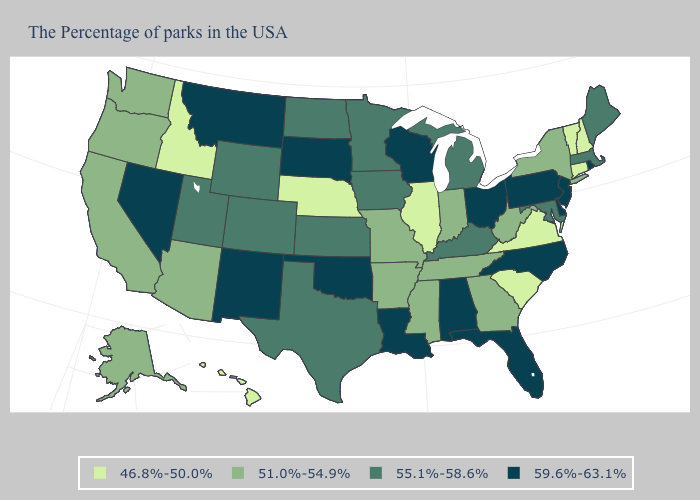What is the lowest value in the MidWest?
Short answer required. 46.8%-50.0%. Does Virginia have the lowest value in the USA?
Short answer required. Yes. Does Alabama have the highest value in the USA?
Be succinct. Yes. Name the states that have a value in the range 51.0%-54.9%?
Answer briefly. New York, West Virginia, Georgia, Indiana, Tennessee, Mississippi, Missouri, Arkansas, Arizona, California, Washington, Oregon, Alaska. Does Indiana have a lower value than Nebraska?
Give a very brief answer. No. Among the states that border Washington , does Oregon have the highest value?
Answer briefly. Yes. Does Rhode Island have the highest value in the USA?
Answer briefly. Yes. Among the states that border Illinois , does Iowa have the highest value?
Quick response, please. No. Is the legend a continuous bar?
Give a very brief answer. No. Name the states that have a value in the range 51.0%-54.9%?
Short answer required. New York, West Virginia, Georgia, Indiana, Tennessee, Mississippi, Missouri, Arkansas, Arizona, California, Washington, Oregon, Alaska. Among the states that border Indiana , which have the lowest value?
Write a very short answer. Illinois. How many symbols are there in the legend?
Write a very short answer. 4. Name the states that have a value in the range 51.0%-54.9%?
Concise answer only. New York, West Virginia, Georgia, Indiana, Tennessee, Mississippi, Missouri, Arkansas, Arizona, California, Washington, Oregon, Alaska. What is the value of Montana?
Concise answer only. 59.6%-63.1%. Does Ohio have the same value as New York?
Concise answer only. No. 